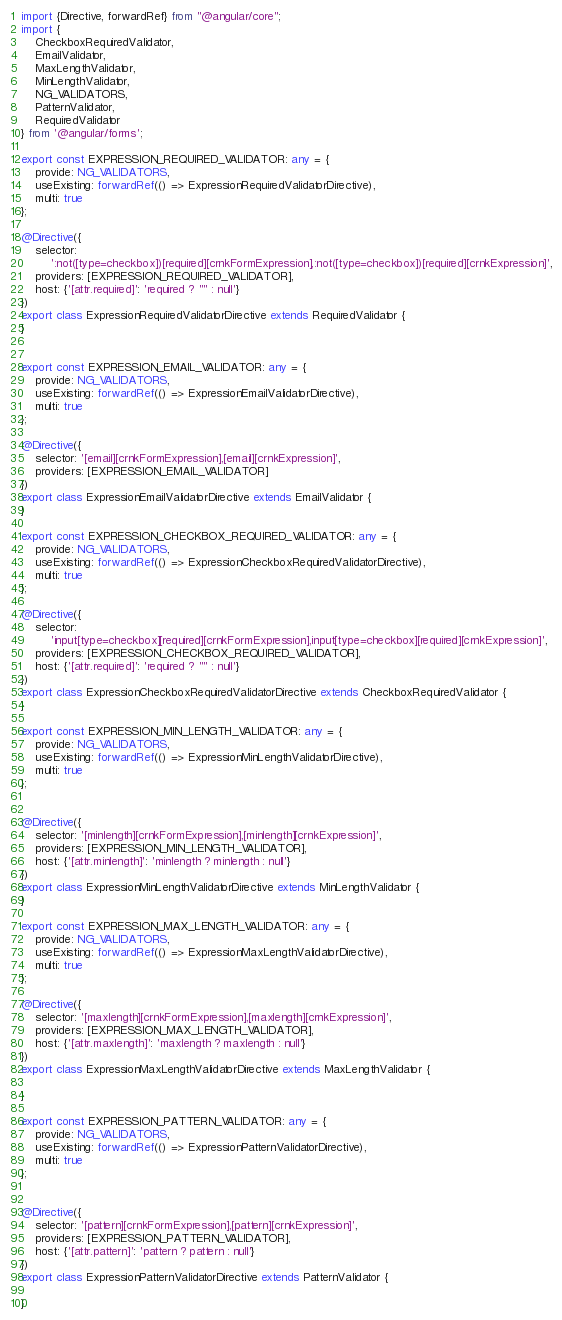<code> <loc_0><loc_0><loc_500><loc_500><_TypeScript_>import {Directive, forwardRef} from "@angular/core";
import {
	CheckboxRequiredValidator,
	EmailValidator,
	MaxLengthValidator,
	MinLengthValidator,
	NG_VALIDATORS,
	PatternValidator,
	RequiredValidator
} from '@angular/forms';

export const EXPRESSION_REQUIRED_VALIDATOR: any = {
	provide: NG_VALIDATORS,
	useExisting: forwardRef(() => ExpressionRequiredValidatorDirective),
	multi: true
};

@Directive({
	selector:
		':not([type=checkbox])[required][crnkFormExpression],:not([type=checkbox])[required][crnkExpression]',
	providers: [EXPRESSION_REQUIRED_VALIDATOR],
	host: {'[attr.required]': 'required ? "" : null'}
})
export class ExpressionRequiredValidatorDirective extends RequiredValidator {
}


export const EXPRESSION_EMAIL_VALIDATOR: any = {
	provide: NG_VALIDATORS,
	useExisting: forwardRef(() => ExpressionEmailValidatorDirective),
	multi: true
};

@Directive({
	selector: '[email][crnkFormExpression],[email][crnkExpression]',
	providers: [EXPRESSION_EMAIL_VALIDATOR]
})
export class ExpressionEmailValidatorDirective extends EmailValidator {
}

export const EXPRESSION_CHECKBOX_REQUIRED_VALIDATOR: any = {
	provide: NG_VALIDATORS,
	useExisting: forwardRef(() => ExpressionCheckboxRequiredValidatorDirective),
	multi: true
};

@Directive({
	selector:
		'input[type=checkbox][required][crnkFormExpression],input[type=checkbox][required][crnkExpression]',
	providers: [EXPRESSION_CHECKBOX_REQUIRED_VALIDATOR],
	host: {'[attr.required]': 'required ? "" : null'}
})
export class ExpressionCheckboxRequiredValidatorDirective extends CheckboxRequiredValidator {
}

export const EXPRESSION_MIN_LENGTH_VALIDATOR: any = {
	provide: NG_VALIDATORS,
	useExisting: forwardRef(() => ExpressionMinLengthValidatorDirective),
	multi: true
};


@Directive({
	selector: '[minlength][crnkFormExpression],[minlength][crnkExpression]',
	providers: [EXPRESSION_MIN_LENGTH_VALIDATOR],
	host: {'[attr.minlength]': 'minlength ? minlength : null'}
})
export class ExpressionMinLengthValidatorDirective extends MinLengthValidator {
}

export const EXPRESSION_MAX_LENGTH_VALIDATOR: any = {
	provide: NG_VALIDATORS,
	useExisting: forwardRef(() => ExpressionMaxLengthValidatorDirective),
	multi: true
};

@Directive({
	selector: '[maxlength][crnkFormExpression],[maxlength][crnkExpression]',
	providers: [EXPRESSION_MAX_LENGTH_VALIDATOR],
	host: {'[attr.maxlength]': 'maxlength ? maxlength : null'}
})
export class ExpressionMaxLengthValidatorDirective extends MaxLengthValidator {

}

export const EXPRESSION_PATTERN_VALIDATOR: any = {
	provide: NG_VALIDATORS,
	useExisting: forwardRef(() => ExpressionPatternValidatorDirective),
	multi: true
};


@Directive({
	selector: '[pattern][crnkFormExpression],[pattern][crnkExpression]',
	providers: [EXPRESSION_PATTERN_VALIDATOR],
	host: {'[attr.pattern]': 'pattern ? pattern : null'}
})
export class ExpressionPatternValidatorDirective extends PatternValidator {

}</code> 